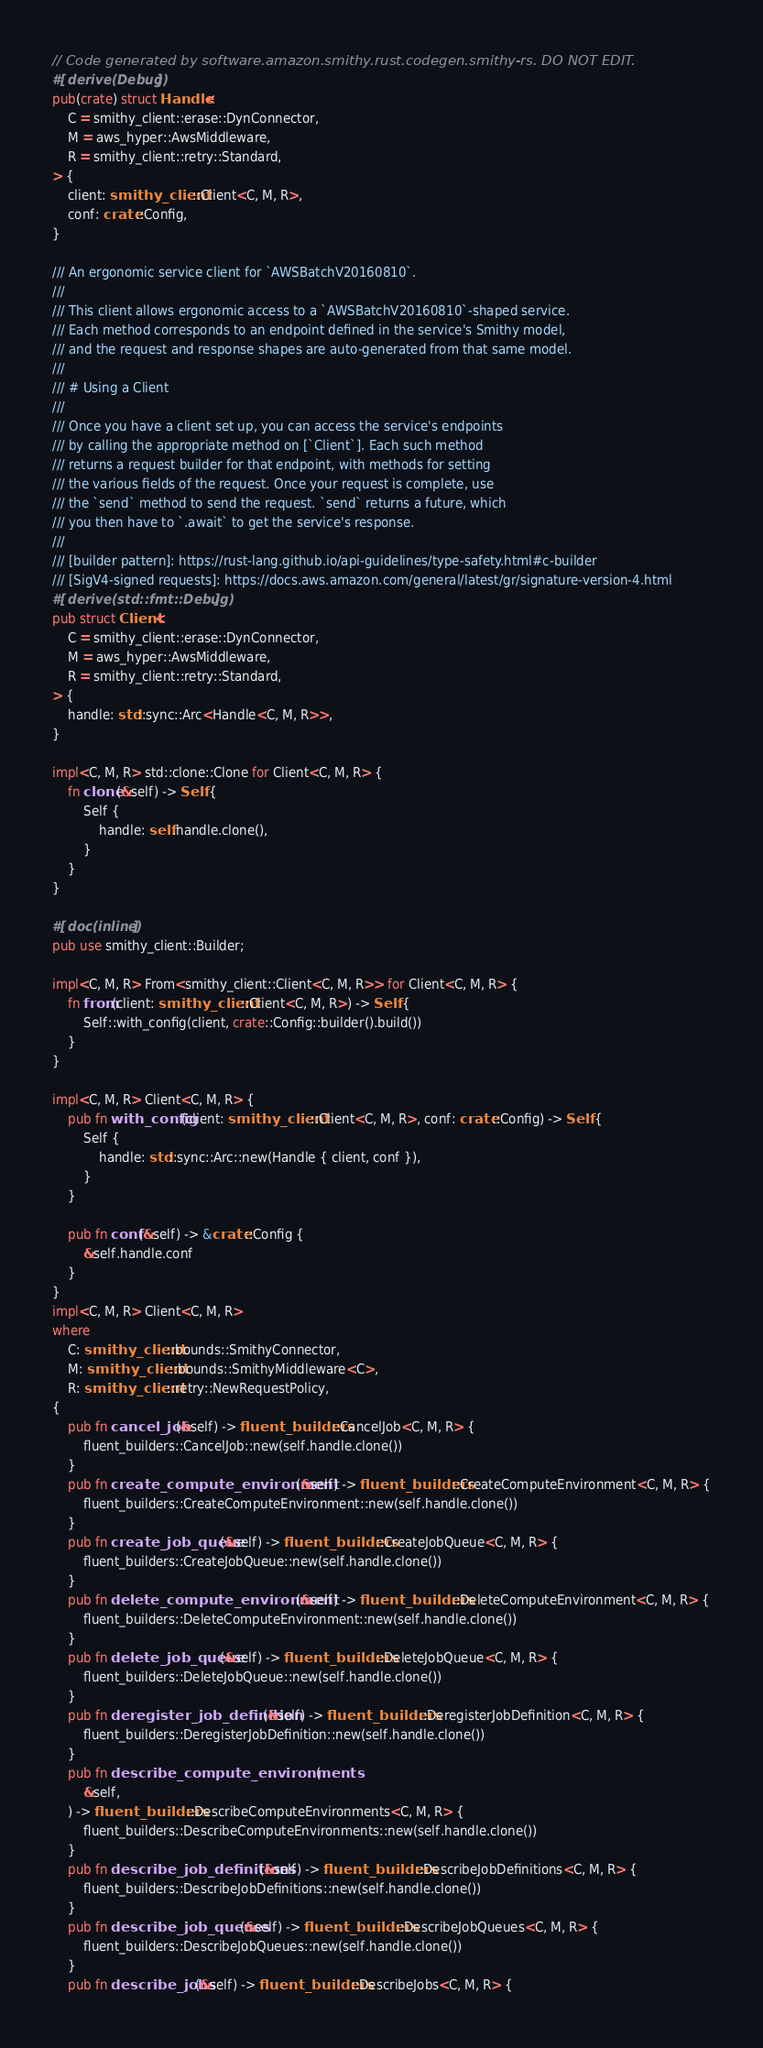<code> <loc_0><loc_0><loc_500><loc_500><_Rust_>// Code generated by software.amazon.smithy.rust.codegen.smithy-rs. DO NOT EDIT.
#[derive(Debug)]
pub(crate) struct Handle<
    C = smithy_client::erase::DynConnector,
    M = aws_hyper::AwsMiddleware,
    R = smithy_client::retry::Standard,
> {
    client: smithy_client::Client<C, M, R>,
    conf: crate::Config,
}

/// An ergonomic service client for `AWSBatchV20160810`.
///
/// This client allows ergonomic access to a `AWSBatchV20160810`-shaped service.
/// Each method corresponds to an endpoint defined in the service's Smithy model,
/// and the request and response shapes are auto-generated from that same model.
///
/// # Using a Client
///
/// Once you have a client set up, you can access the service's endpoints
/// by calling the appropriate method on [`Client`]. Each such method
/// returns a request builder for that endpoint, with methods for setting
/// the various fields of the request. Once your request is complete, use
/// the `send` method to send the request. `send` returns a future, which
/// you then have to `.await` to get the service's response.
///
/// [builder pattern]: https://rust-lang.github.io/api-guidelines/type-safety.html#c-builder
/// [SigV4-signed requests]: https://docs.aws.amazon.com/general/latest/gr/signature-version-4.html
#[derive(std::fmt::Debug)]
pub struct Client<
    C = smithy_client::erase::DynConnector,
    M = aws_hyper::AwsMiddleware,
    R = smithy_client::retry::Standard,
> {
    handle: std::sync::Arc<Handle<C, M, R>>,
}

impl<C, M, R> std::clone::Clone for Client<C, M, R> {
    fn clone(&self) -> Self {
        Self {
            handle: self.handle.clone(),
        }
    }
}

#[doc(inline)]
pub use smithy_client::Builder;

impl<C, M, R> From<smithy_client::Client<C, M, R>> for Client<C, M, R> {
    fn from(client: smithy_client::Client<C, M, R>) -> Self {
        Self::with_config(client, crate::Config::builder().build())
    }
}

impl<C, M, R> Client<C, M, R> {
    pub fn with_config(client: smithy_client::Client<C, M, R>, conf: crate::Config) -> Self {
        Self {
            handle: std::sync::Arc::new(Handle { client, conf }),
        }
    }

    pub fn conf(&self) -> &crate::Config {
        &self.handle.conf
    }
}
impl<C, M, R> Client<C, M, R>
where
    C: smithy_client::bounds::SmithyConnector,
    M: smithy_client::bounds::SmithyMiddleware<C>,
    R: smithy_client::retry::NewRequestPolicy,
{
    pub fn cancel_job(&self) -> fluent_builders::CancelJob<C, M, R> {
        fluent_builders::CancelJob::new(self.handle.clone())
    }
    pub fn create_compute_environment(&self) -> fluent_builders::CreateComputeEnvironment<C, M, R> {
        fluent_builders::CreateComputeEnvironment::new(self.handle.clone())
    }
    pub fn create_job_queue(&self) -> fluent_builders::CreateJobQueue<C, M, R> {
        fluent_builders::CreateJobQueue::new(self.handle.clone())
    }
    pub fn delete_compute_environment(&self) -> fluent_builders::DeleteComputeEnvironment<C, M, R> {
        fluent_builders::DeleteComputeEnvironment::new(self.handle.clone())
    }
    pub fn delete_job_queue(&self) -> fluent_builders::DeleteJobQueue<C, M, R> {
        fluent_builders::DeleteJobQueue::new(self.handle.clone())
    }
    pub fn deregister_job_definition(&self) -> fluent_builders::DeregisterJobDefinition<C, M, R> {
        fluent_builders::DeregisterJobDefinition::new(self.handle.clone())
    }
    pub fn describe_compute_environments(
        &self,
    ) -> fluent_builders::DescribeComputeEnvironments<C, M, R> {
        fluent_builders::DescribeComputeEnvironments::new(self.handle.clone())
    }
    pub fn describe_job_definitions(&self) -> fluent_builders::DescribeJobDefinitions<C, M, R> {
        fluent_builders::DescribeJobDefinitions::new(self.handle.clone())
    }
    pub fn describe_job_queues(&self) -> fluent_builders::DescribeJobQueues<C, M, R> {
        fluent_builders::DescribeJobQueues::new(self.handle.clone())
    }
    pub fn describe_jobs(&self) -> fluent_builders::DescribeJobs<C, M, R> {</code> 